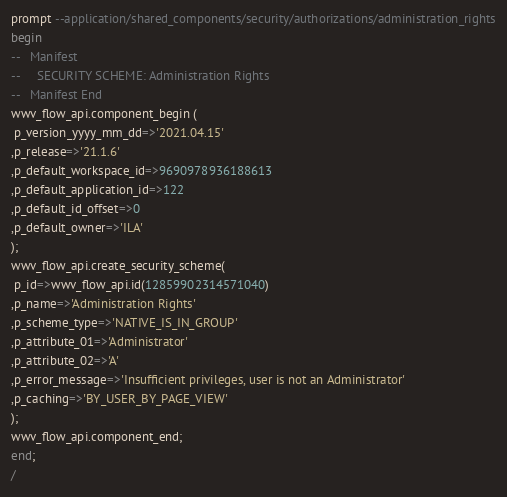<code> <loc_0><loc_0><loc_500><loc_500><_SQL_>prompt --application/shared_components/security/authorizations/administration_rights
begin
--   Manifest
--     SECURITY SCHEME: Administration Rights
--   Manifest End
wwv_flow_api.component_begin (
 p_version_yyyy_mm_dd=>'2021.04.15'
,p_release=>'21.1.6'
,p_default_workspace_id=>9690978936188613
,p_default_application_id=>122
,p_default_id_offset=>0
,p_default_owner=>'ILA'
);
wwv_flow_api.create_security_scheme(
 p_id=>wwv_flow_api.id(12859902314571040)
,p_name=>'Administration Rights'
,p_scheme_type=>'NATIVE_IS_IN_GROUP'
,p_attribute_01=>'Administrator'
,p_attribute_02=>'A'
,p_error_message=>'Insufficient privileges, user is not an Administrator'
,p_caching=>'BY_USER_BY_PAGE_VIEW'
);
wwv_flow_api.component_end;
end;
/
</code> 